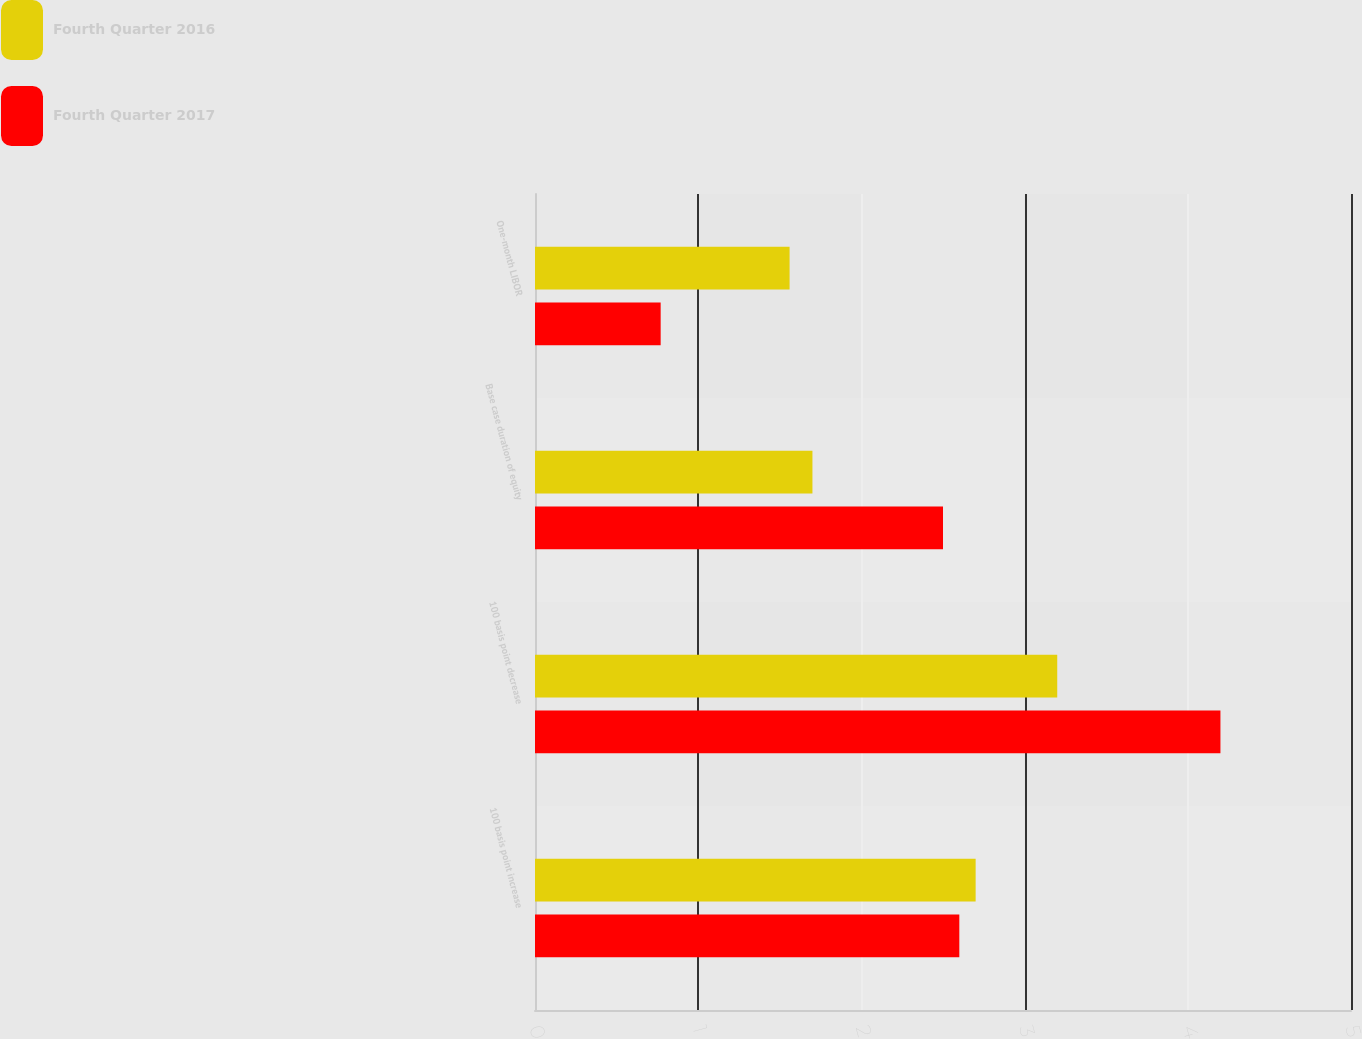Convert chart. <chart><loc_0><loc_0><loc_500><loc_500><stacked_bar_chart><ecel><fcel>100 basis point increase<fcel>100 basis point decrease<fcel>Base case duration of equity<fcel>One-month LIBOR<nl><fcel>Fourth Quarter 2016<fcel>2.7<fcel>3.2<fcel>1.7<fcel>1.56<nl><fcel>Fourth Quarter 2017<fcel>2.6<fcel>4.2<fcel>2.5<fcel>0.77<nl></chart> 